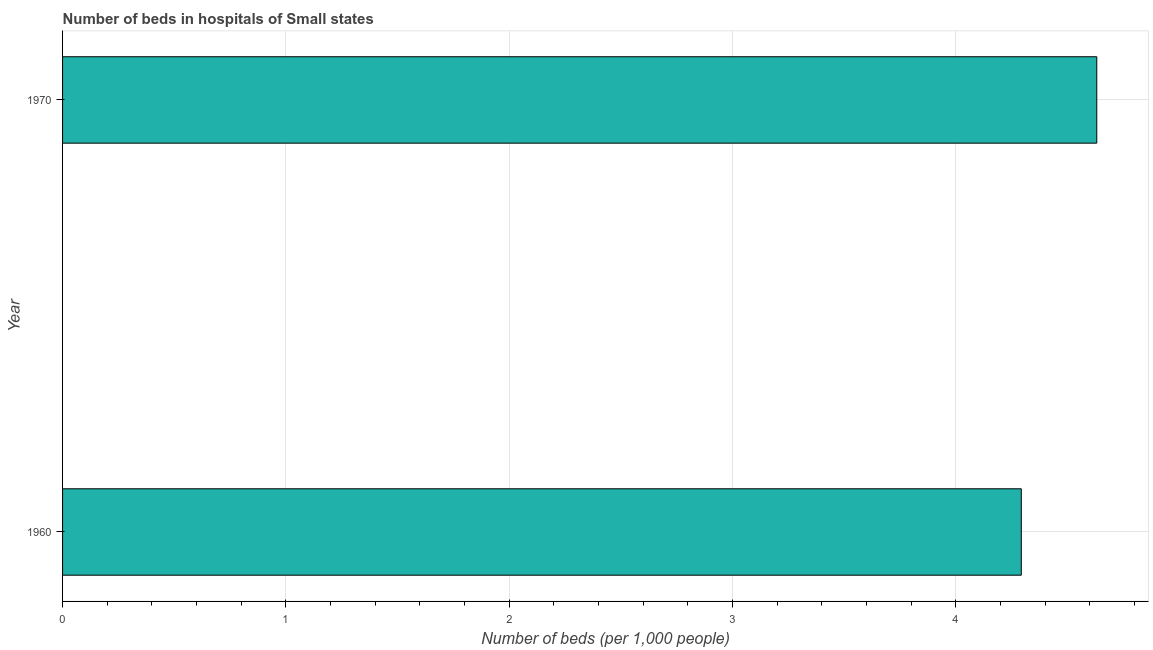Does the graph contain any zero values?
Your answer should be compact. No. What is the title of the graph?
Your response must be concise. Number of beds in hospitals of Small states. What is the label or title of the X-axis?
Your response must be concise. Number of beds (per 1,0 people). What is the label or title of the Y-axis?
Provide a short and direct response. Year. What is the number of hospital beds in 1970?
Give a very brief answer. 4.63. Across all years, what is the maximum number of hospital beds?
Ensure brevity in your answer.  4.63. Across all years, what is the minimum number of hospital beds?
Offer a terse response. 4.29. In which year was the number of hospital beds minimum?
Offer a very short reply. 1960. What is the sum of the number of hospital beds?
Your answer should be compact. 8.92. What is the difference between the number of hospital beds in 1960 and 1970?
Ensure brevity in your answer.  -0.34. What is the average number of hospital beds per year?
Make the answer very short. 4.46. What is the median number of hospital beds?
Offer a very short reply. 4.46. What is the ratio of the number of hospital beds in 1960 to that in 1970?
Provide a short and direct response. 0.93. In how many years, is the number of hospital beds greater than the average number of hospital beds taken over all years?
Offer a terse response. 1. How many bars are there?
Provide a short and direct response. 2. Are all the bars in the graph horizontal?
Make the answer very short. Yes. What is the Number of beds (per 1,000 people) in 1960?
Offer a terse response. 4.29. What is the Number of beds (per 1,000 people) of 1970?
Offer a very short reply. 4.63. What is the difference between the Number of beds (per 1,000 people) in 1960 and 1970?
Your answer should be compact. -0.34. What is the ratio of the Number of beds (per 1,000 people) in 1960 to that in 1970?
Give a very brief answer. 0.93. 